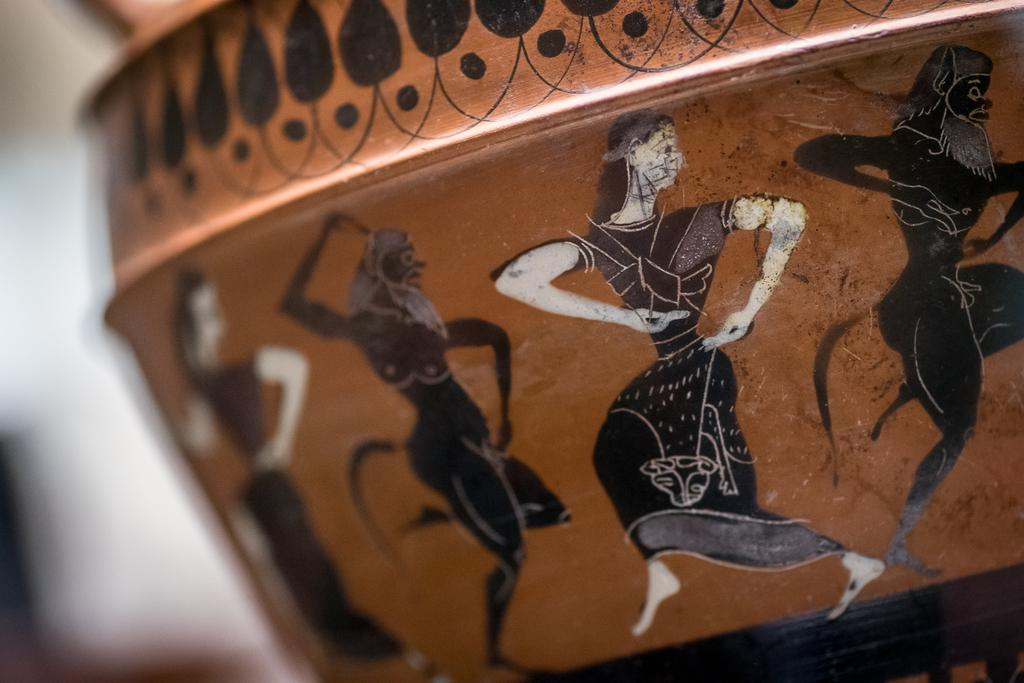What is located in the foreground of the image? There are paintings in the foreground of the image. What is the paintings placed on? The paintings are on a pot. What type of cattle can be seen attending the meeting in the image? There is no meeting or cattle present in the image; it features paintings on a pot. What fictional character is depicted in the painting on the pot? The provided facts do not mention any specific characters or subjects depicted in the paintings, so we cannot determine if any are fictional. 